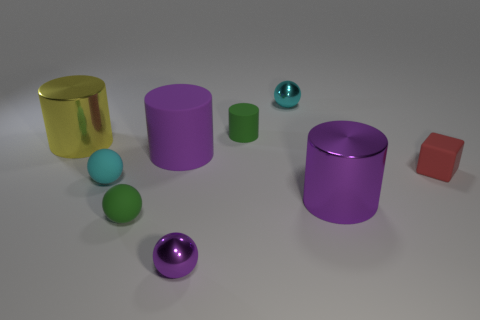Subtract 1 cylinders. How many cylinders are left? 3 Add 1 tiny shiny balls. How many objects exist? 10 Subtract all cubes. How many objects are left? 8 Subtract 0 red cylinders. How many objects are left? 9 Subtract all large purple shiny balls. Subtract all big purple things. How many objects are left? 7 Add 4 big objects. How many big objects are left? 7 Add 8 big purple shiny objects. How many big purple shiny objects exist? 9 